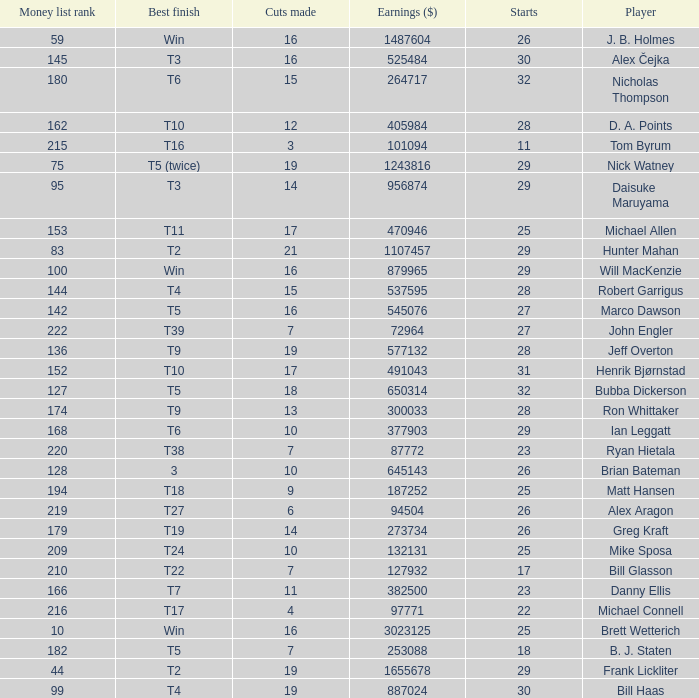What is the minimum number of cuts made for Hunter Mahan? 21.0. 